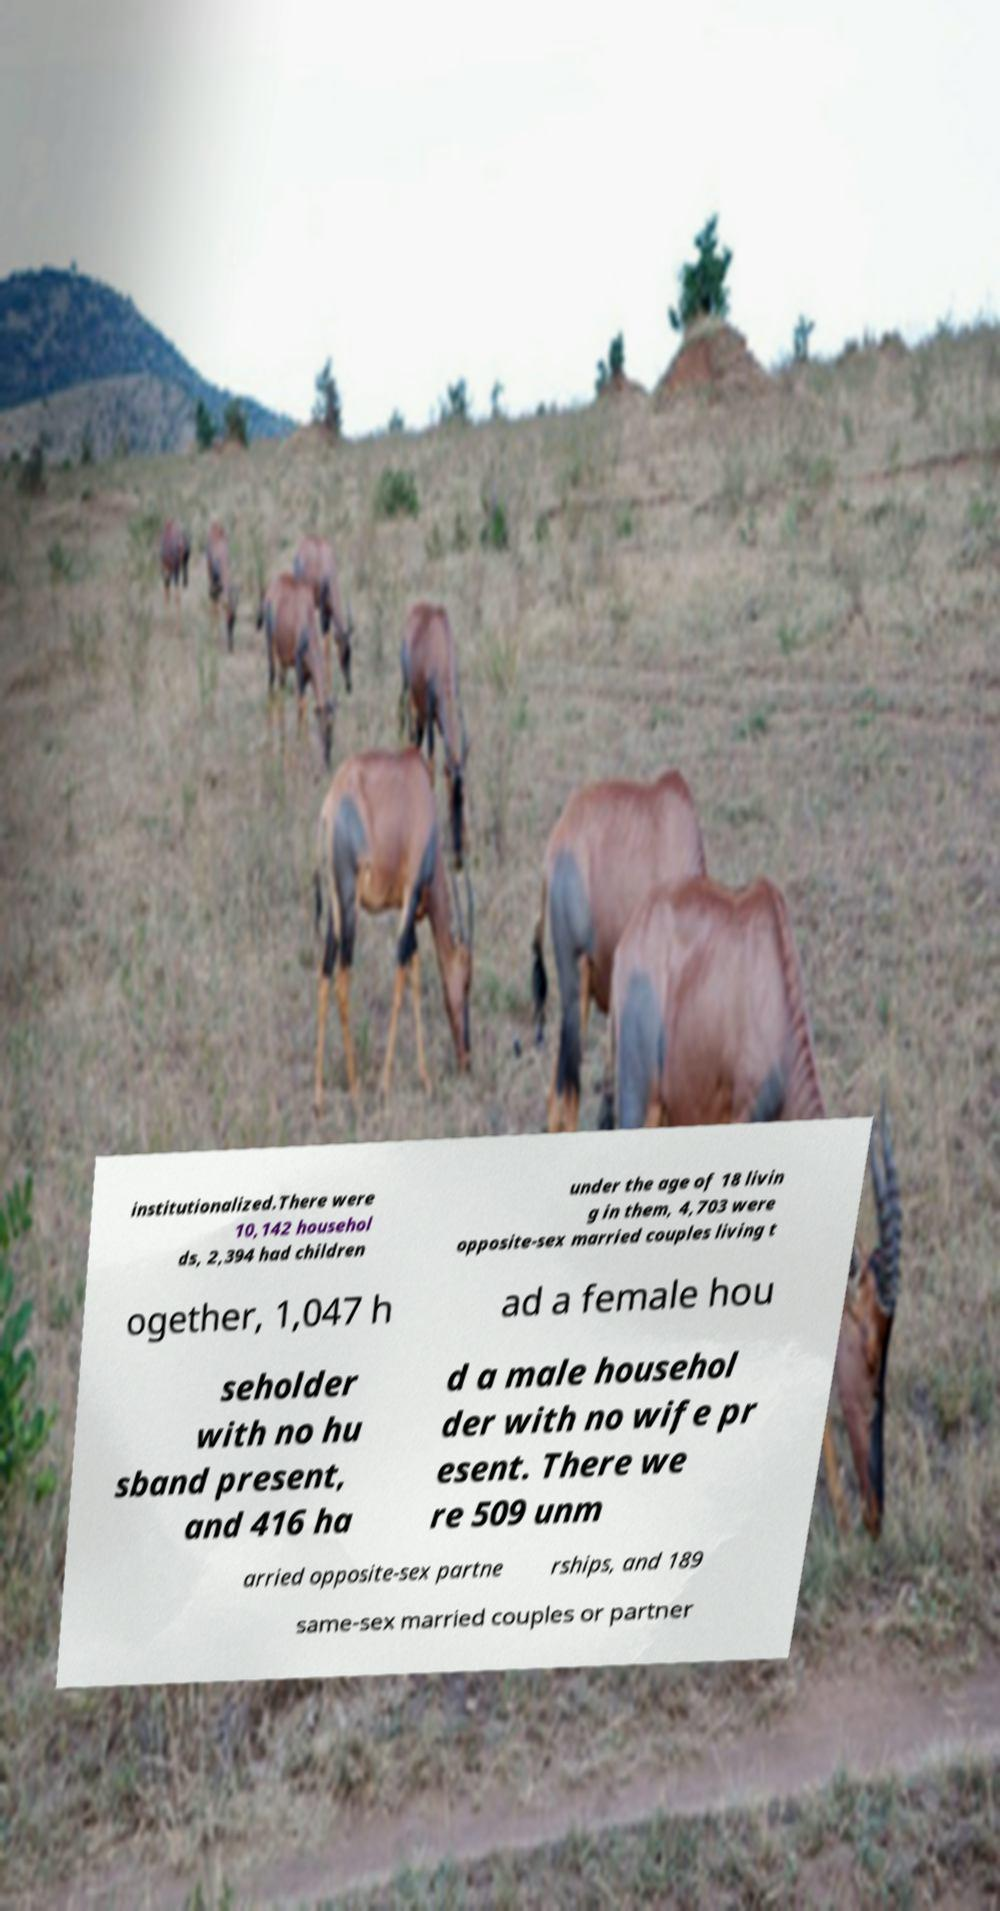Please read and relay the text visible in this image. What does it say? institutionalized.There were 10,142 househol ds, 2,394 had children under the age of 18 livin g in them, 4,703 were opposite-sex married couples living t ogether, 1,047 h ad a female hou seholder with no hu sband present, and 416 ha d a male househol der with no wife pr esent. There we re 509 unm arried opposite-sex partne rships, and 189 same-sex married couples or partner 